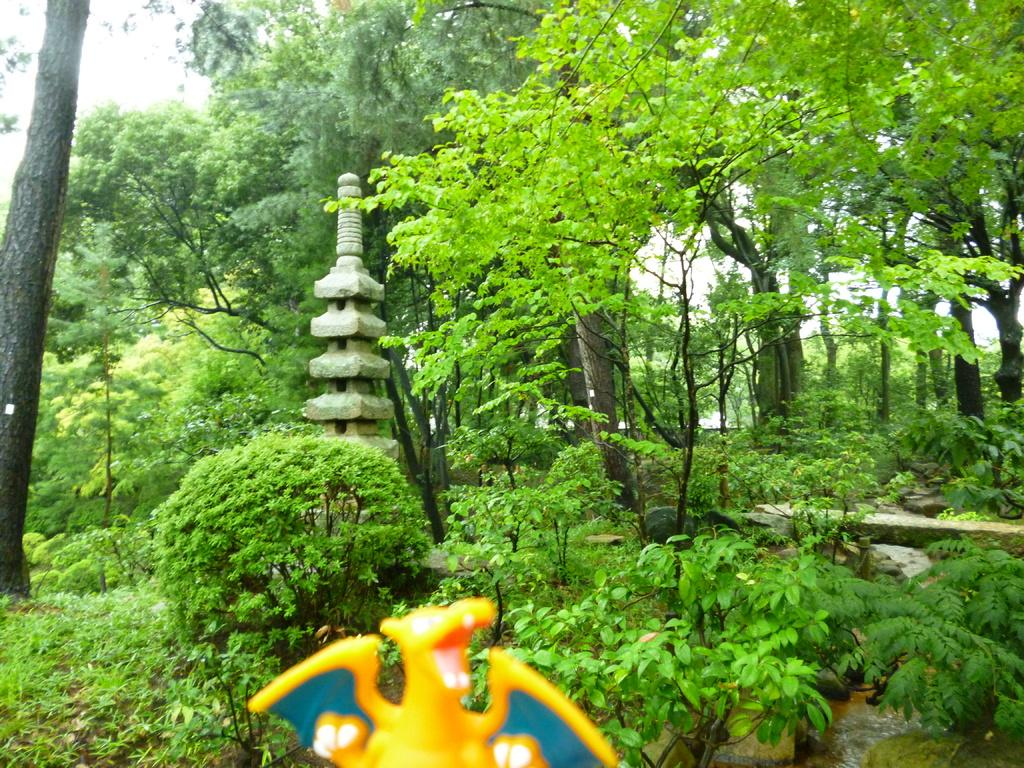What is the color of the toy at the bottom of the image? The toy at the bottom of the image is yellow. What can be seen in the background of the image? There are many plants and trees in the background of the image. What architectural feature is visible in the background? There is a pillar in the background of the image. How does the drum shake in the image? There is no drum present in the image, so it cannot shake. 